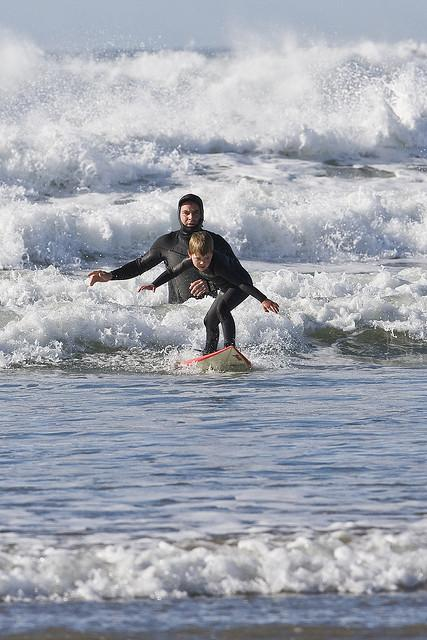Why are they dressed in black? Please explain your reasoning. wetsuits. The wetsuits and colour black keep the heat inside the body so they do not get too cold in the natural elements of the sea. 